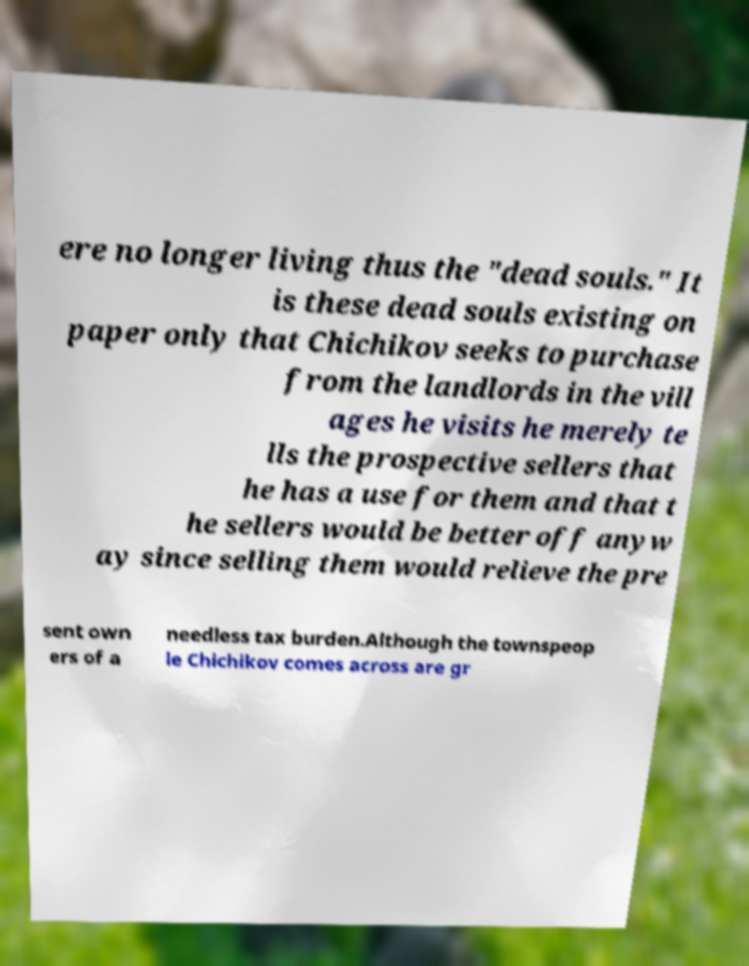Please identify and transcribe the text found in this image. ere no longer living thus the "dead souls." It is these dead souls existing on paper only that Chichikov seeks to purchase from the landlords in the vill ages he visits he merely te lls the prospective sellers that he has a use for them and that t he sellers would be better off anyw ay since selling them would relieve the pre sent own ers of a needless tax burden.Although the townspeop le Chichikov comes across are gr 